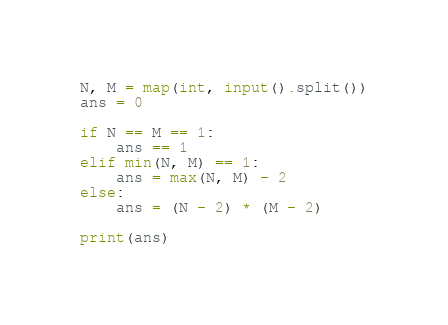<code> <loc_0><loc_0><loc_500><loc_500><_Python_>N, M = map(int, input().split())
ans = 0

if N == M == 1:
    ans == 1
elif min(N, M) == 1:
    ans = max(N, M) - 2
else:
    ans = (N - 2) * (M - 2)

print(ans)</code> 